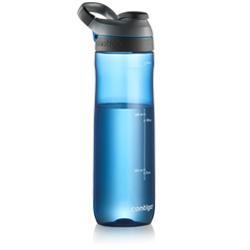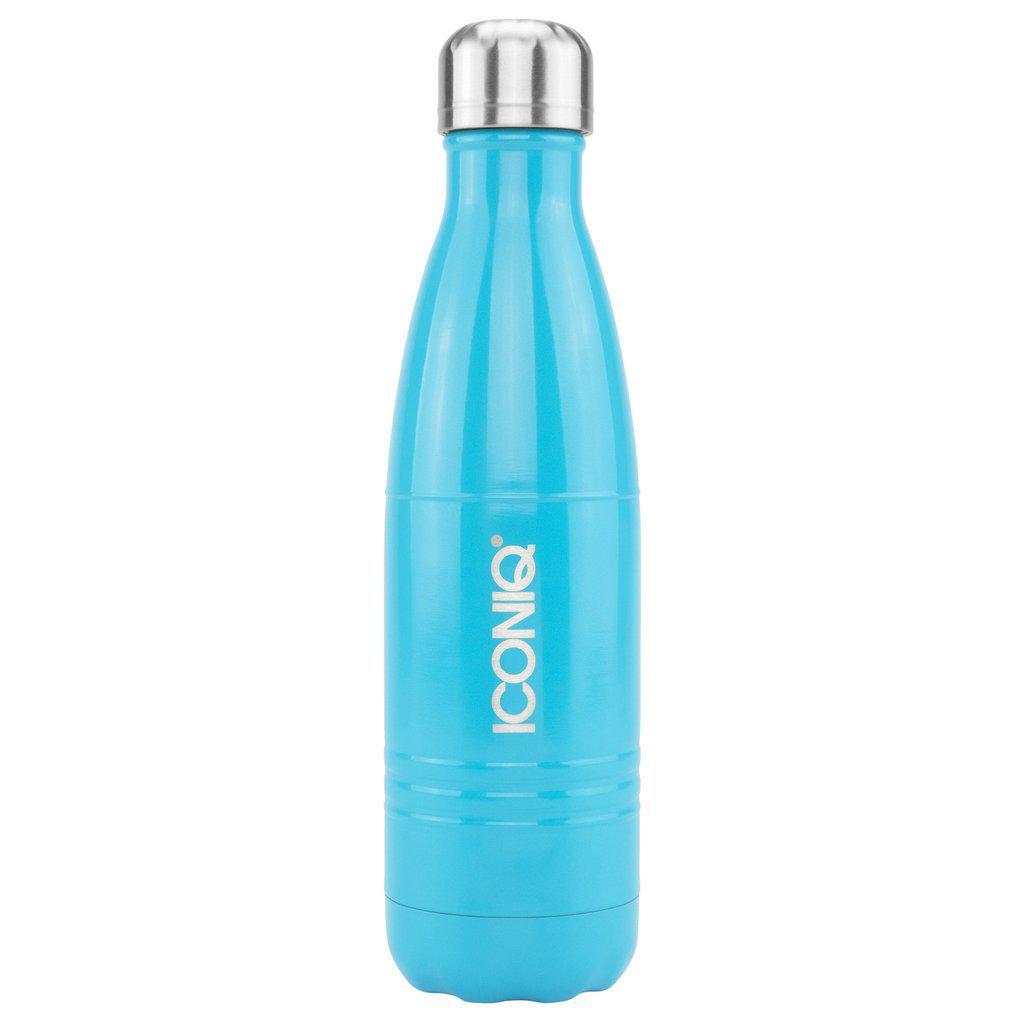The first image is the image on the left, the second image is the image on the right. Evaluate the accuracy of this statement regarding the images: "There is exactly one water bottle in the image on the left.". Is it true? Answer yes or no. Yes. 